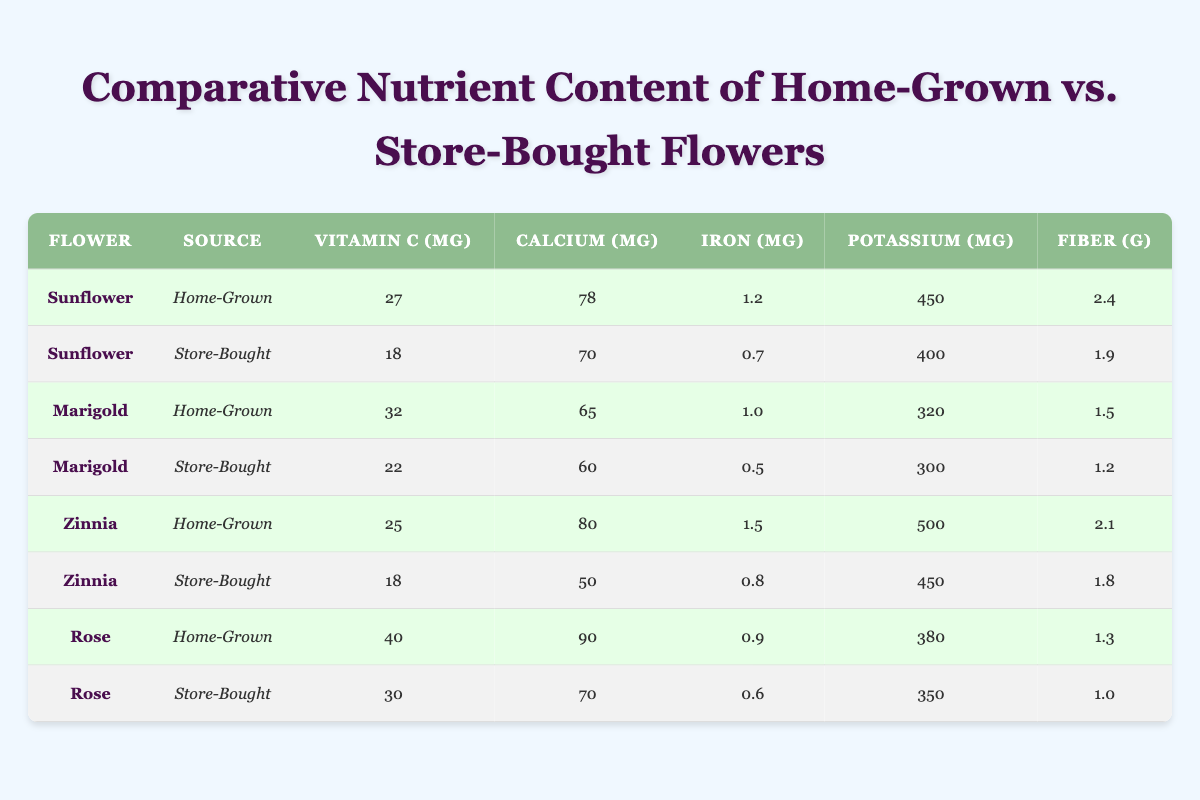What is the vitamin C content of a home-grown sunflower? The table indicates that the vitamin C content for a home-grown sunflower is listed as 27 mg.
Answer: 27 mg Which flower has the highest calcium content when home-grown? By comparing the calcium content across all home-grown flowers, the table shows that the sunflower has 78 mg, marigold has 65 mg, zinnia has 80 mg, and rose has 90 mg. The highest value is from the rose at 90 mg.
Answer: Rose Is the fiber content in store-bought zinnias more than that in home-grown zinnias? The table lists the fiber content for store-bought zinnias as 1.8 g and for home-grown zinnias as 2.1 g. Since 2.1 is greater than 1.8, it is false that the fiber content in store-bought zinnias is more.
Answer: No What is the difference in potassium content between home-grown and store-bought marigolds? The potassium content for home-grown marigolds is 320 mg, and for store-bought marigolds, it is 300 mg. The difference is calculated as 320 - 300 = 20 mg.
Answer: 20 mg Do home-grown flowers generally have more vitamin C than store-bought flowers? By analyzing the vitamin C contents: home-grown sunflower (27 mg), marigold (32 mg), zinnia (25 mg), and rose (40 mg) versus store-bought sunflower (18 mg), marigold (22 mg), zinnia (18 mg), and rose (30 mg). All home-grown flowers have higher vitamin C contents than their store-bought counterparts.
Answer: Yes What is the average iron content of home-grown flowers? The iron content for home-grown flowers is 1.2 mg (sunflower), 1.0 mg (marigold), 1.5 mg (zinnia), and 0.9 mg (rose). Adding these gives 1.2 + 1.0 + 1.5 + 0.9 = 4.6 mg, and dividing by 4 (the number of home-grown flowers) gives an average of 4.6 / 4 = 1.15 mg.
Answer: 1.15 mg Which flower, home-grown or store-bought, has the lowest calcium content? Examining the calcium content, home-grown marigold has 65 mg, home-grown sunflower 78 mg, home-grown zinnia 80 mg, home-grown rose 90 mg, store-bought marigold 60 mg, store-bought sunflower 70 mg, store-bought zinnia 50 mg, and store-bought rose 70 mg. The store-bought zinnia has the lowest amount at 50 mg.
Answer: Store-bought zinnia How much more potassium is found in home-grown sunflowers compared to store-bought sunflowers? The potassium content for home-grown sunflowers is 450 mg and for store-bought sunflowers is 400 mg. The difference is calculated as 450 - 400 = 50 mg; therefore, home-grown sunflowers have 50 mg more potassium.
Answer: 50 mg 